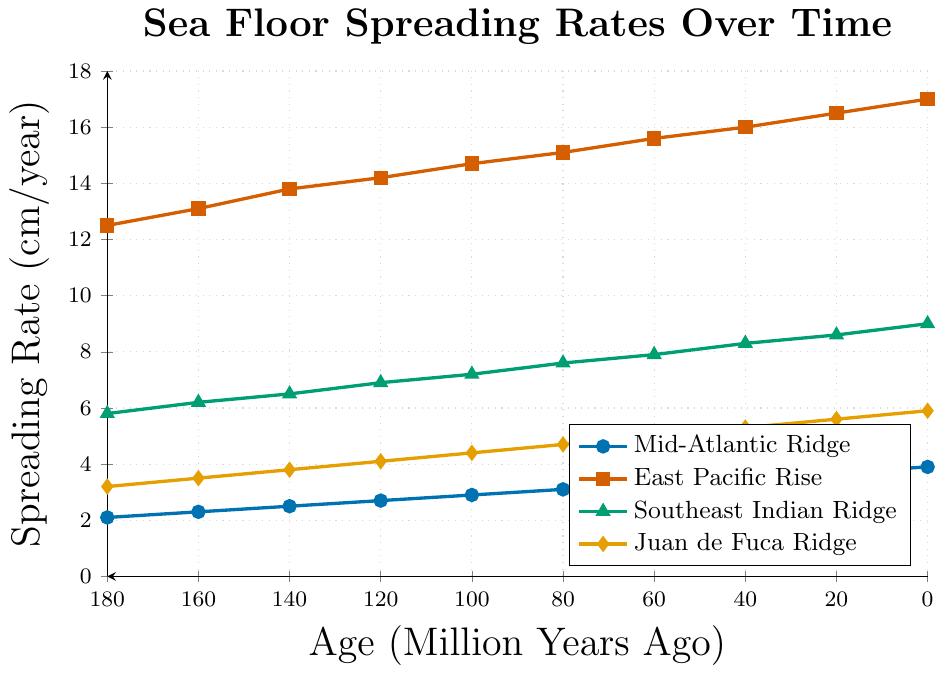What is the overall trend in the spreading rate of the Mid-Atlantic Ridge over the last 180 million years? The line chart shows that the spreading rate of the Mid-Atlantic Ridge has increased consistently from 2.1 cm/year at 180 million years ago to 3.9 cm/year at the present.
Answer: Increasing trend Which mid-ocean ridge has the highest spreading rate at present? By looking at the highest point on each line at the present (0 million years ago), the East Pacific Rise has the highest spreading rate of 17.0 cm/year.
Answer: East Pacific Rise What is the difference in the spreading rates between the East Pacific Rise and the Juan de Fuca Ridge at 100 million years ago? The spreading rate for the East Pacific Rise at 100 million years ago is 14.7 cm/year, while for the Juan de Fuca Ridge, it is 4.4 cm/year. The difference is 14.7 - 4.4 = 10.3 cm/year.
Answer: 10.3 cm/year Which mid-ocean ridge has shown the greatest change in spreading rate over the last 180 million years? By examining the vertical distance covered by each line over the period, the East Pacific Rise exhibits the greatest change, increasing from 12.5 cm/year to 17.0 cm/year, a change of 4.5 cm/year.
Answer: East Pacific Rise How does the spreading rate of the Southeast Indian Ridge 80 million years ago compare to the spreading rate of the Juan de Fuca Ridge at 20 million years ago? The spreading rate for the Southeast Indian Ridge at 80 million years ago is 7.6 cm/year, while for the Juan de Fuca Ridge at 20 million years ago, it is 5.6 cm/year. Therefore, the Southeast Indian Ridge has a higher spreading rate by 2.0 cm/year.
Answer: 7.6 cm/year vs 5.6 cm/year What is the average spreading rate of the Mid-Atlantic Ridge over the entire period shown in the chart? The data points for the Mid-Atlantic Ridge are: 2.1, 2.3, 2.5, 2.7, 2.9, 3.1, 3.3, 3.5, 3.7, 3.9. Sum these values and divide by 10: (2.1 + 2.3 + 2.5 + 2.7 + 2.9 + 3.1 + 3.3 + 3.5 + 3.7 + 3.9)/10 = 3.0 cm/year.
Answer: 3.0 cm/year At which time point do all four ridges have their highest relative spreading rates simultaneously? By visually inspecting the peaks of all four lines, it is clear that at the present time (0 million years ago), all four ridges are at their highest spreading rates compared to earlier periods.
Answer: Present (0 million years ago) What color represents the Southeast Indian Ridge in the chart? The line corresponding to the Southeast Indian Ridge is marked with a triangle and is colored green.
Answer: Green 